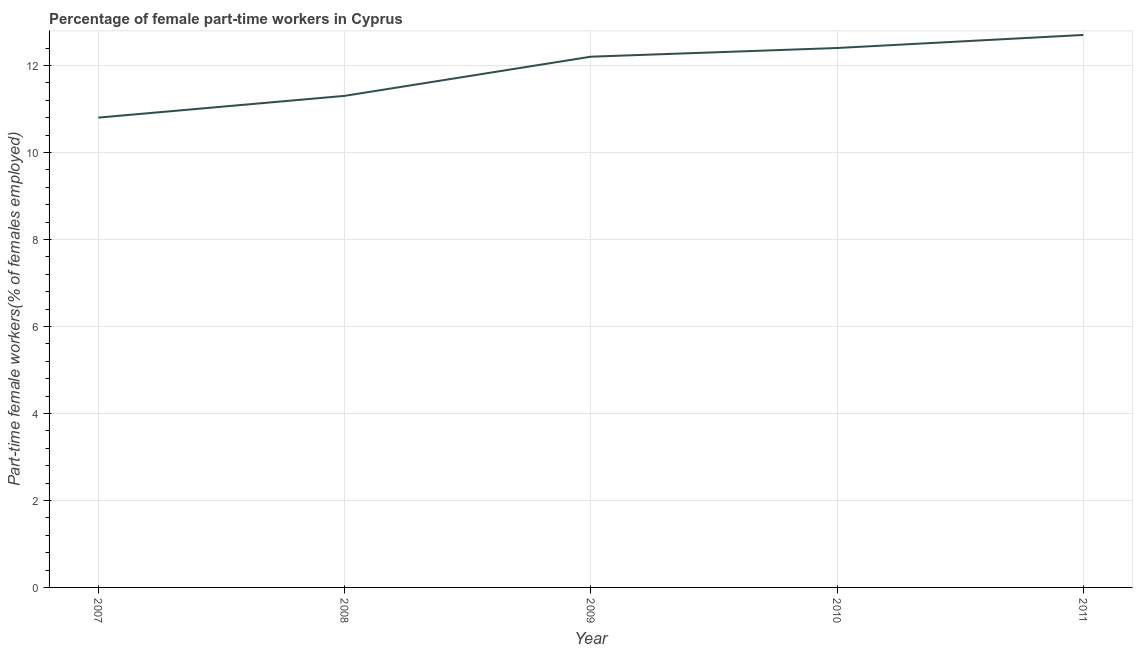What is the percentage of part-time female workers in 2010?
Make the answer very short. 12.4. Across all years, what is the maximum percentage of part-time female workers?
Keep it short and to the point. 12.7. Across all years, what is the minimum percentage of part-time female workers?
Provide a succinct answer. 10.8. In which year was the percentage of part-time female workers maximum?
Give a very brief answer. 2011. What is the sum of the percentage of part-time female workers?
Provide a short and direct response. 59.4. What is the difference between the percentage of part-time female workers in 2008 and 2011?
Keep it short and to the point. -1.4. What is the average percentage of part-time female workers per year?
Your response must be concise. 11.88. What is the median percentage of part-time female workers?
Ensure brevity in your answer.  12.2. Do a majority of the years between 2011 and 2007 (inclusive) have percentage of part-time female workers greater than 8 %?
Your answer should be very brief. Yes. What is the ratio of the percentage of part-time female workers in 2007 to that in 2011?
Your answer should be compact. 0.85. Is the percentage of part-time female workers in 2008 less than that in 2009?
Ensure brevity in your answer.  Yes. What is the difference between the highest and the second highest percentage of part-time female workers?
Your response must be concise. 0.3. Is the sum of the percentage of part-time female workers in 2007 and 2010 greater than the maximum percentage of part-time female workers across all years?
Provide a short and direct response. Yes. What is the difference between the highest and the lowest percentage of part-time female workers?
Your answer should be compact. 1.9. Does the percentage of part-time female workers monotonically increase over the years?
Make the answer very short. Yes. How many lines are there?
Provide a succinct answer. 1. What is the difference between two consecutive major ticks on the Y-axis?
Offer a very short reply. 2. What is the title of the graph?
Your answer should be very brief. Percentage of female part-time workers in Cyprus. What is the label or title of the Y-axis?
Offer a very short reply. Part-time female workers(% of females employed). What is the Part-time female workers(% of females employed) in 2007?
Offer a terse response. 10.8. What is the Part-time female workers(% of females employed) of 2008?
Provide a short and direct response. 11.3. What is the Part-time female workers(% of females employed) in 2009?
Provide a short and direct response. 12.2. What is the Part-time female workers(% of females employed) of 2010?
Make the answer very short. 12.4. What is the Part-time female workers(% of females employed) of 2011?
Offer a very short reply. 12.7. What is the difference between the Part-time female workers(% of females employed) in 2007 and 2008?
Offer a terse response. -0.5. What is the difference between the Part-time female workers(% of females employed) in 2007 and 2011?
Give a very brief answer. -1.9. What is the difference between the Part-time female workers(% of females employed) in 2008 and 2009?
Offer a terse response. -0.9. What is the difference between the Part-time female workers(% of females employed) in 2008 and 2010?
Ensure brevity in your answer.  -1.1. What is the difference between the Part-time female workers(% of females employed) in 2009 and 2010?
Give a very brief answer. -0.2. What is the difference between the Part-time female workers(% of females employed) in 2009 and 2011?
Provide a short and direct response. -0.5. What is the difference between the Part-time female workers(% of females employed) in 2010 and 2011?
Your response must be concise. -0.3. What is the ratio of the Part-time female workers(% of females employed) in 2007 to that in 2008?
Your answer should be very brief. 0.96. What is the ratio of the Part-time female workers(% of females employed) in 2007 to that in 2009?
Your response must be concise. 0.89. What is the ratio of the Part-time female workers(% of females employed) in 2007 to that in 2010?
Offer a very short reply. 0.87. What is the ratio of the Part-time female workers(% of females employed) in 2007 to that in 2011?
Give a very brief answer. 0.85. What is the ratio of the Part-time female workers(% of females employed) in 2008 to that in 2009?
Your answer should be very brief. 0.93. What is the ratio of the Part-time female workers(% of females employed) in 2008 to that in 2010?
Offer a very short reply. 0.91. What is the ratio of the Part-time female workers(% of females employed) in 2008 to that in 2011?
Your response must be concise. 0.89. What is the ratio of the Part-time female workers(% of females employed) in 2010 to that in 2011?
Provide a succinct answer. 0.98. 